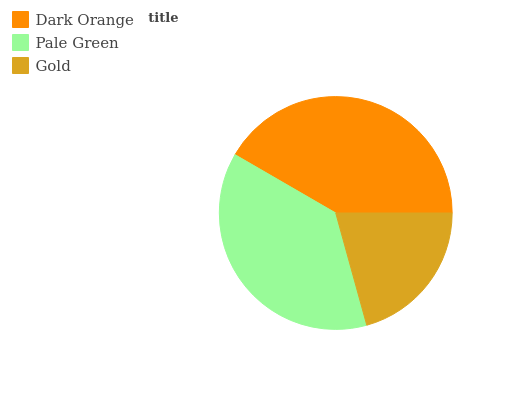Is Gold the minimum?
Answer yes or no. Yes. Is Dark Orange the maximum?
Answer yes or no. Yes. Is Pale Green the minimum?
Answer yes or no. No. Is Pale Green the maximum?
Answer yes or no. No. Is Dark Orange greater than Pale Green?
Answer yes or no. Yes. Is Pale Green less than Dark Orange?
Answer yes or no. Yes. Is Pale Green greater than Dark Orange?
Answer yes or no. No. Is Dark Orange less than Pale Green?
Answer yes or no. No. Is Pale Green the high median?
Answer yes or no. Yes. Is Pale Green the low median?
Answer yes or no. Yes. Is Dark Orange the high median?
Answer yes or no. No. Is Dark Orange the low median?
Answer yes or no. No. 